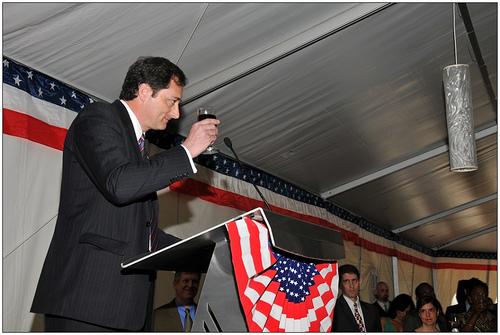How many stars can you see on the flags?
Be succinct. 50. Is the man drinking red wine?
Write a very short answer. Yes. The black thing in front of the man is called what?
Answer briefly. Microphone. How many people are in front of the podium?
Quick response, please. 1. 